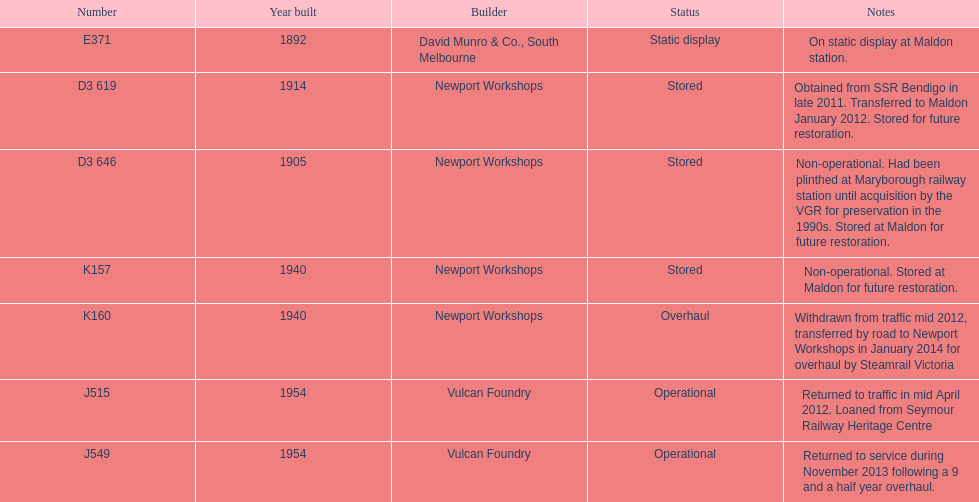How many of the trains were constructed prior to 1940? 3. 